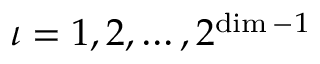Convert formula to latex. <formula><loc_0><loc_0><loc_500><loc_500>\iota = 1 , 2 , \dots , 2 ^ { \dim - 1 }</formula> 